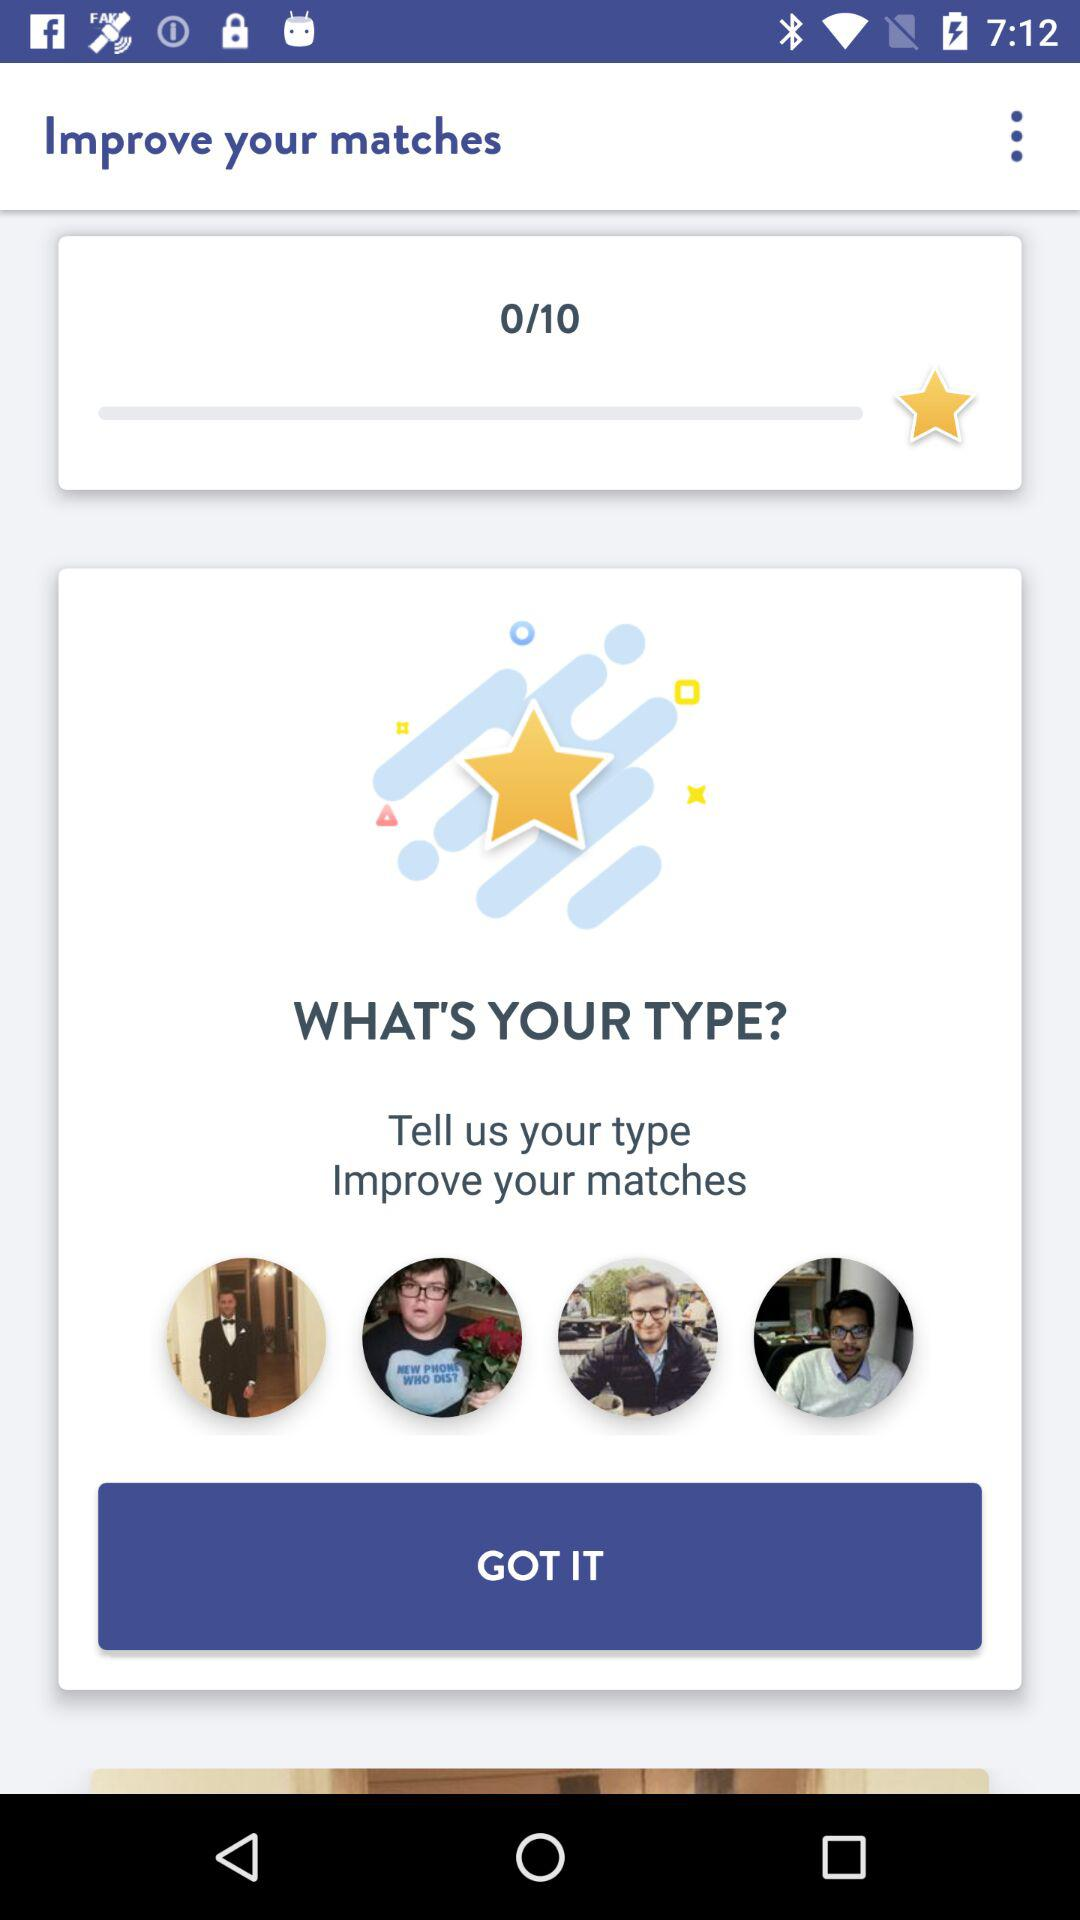What's the number of stars achieved out of 10? The number of stars is 0. 